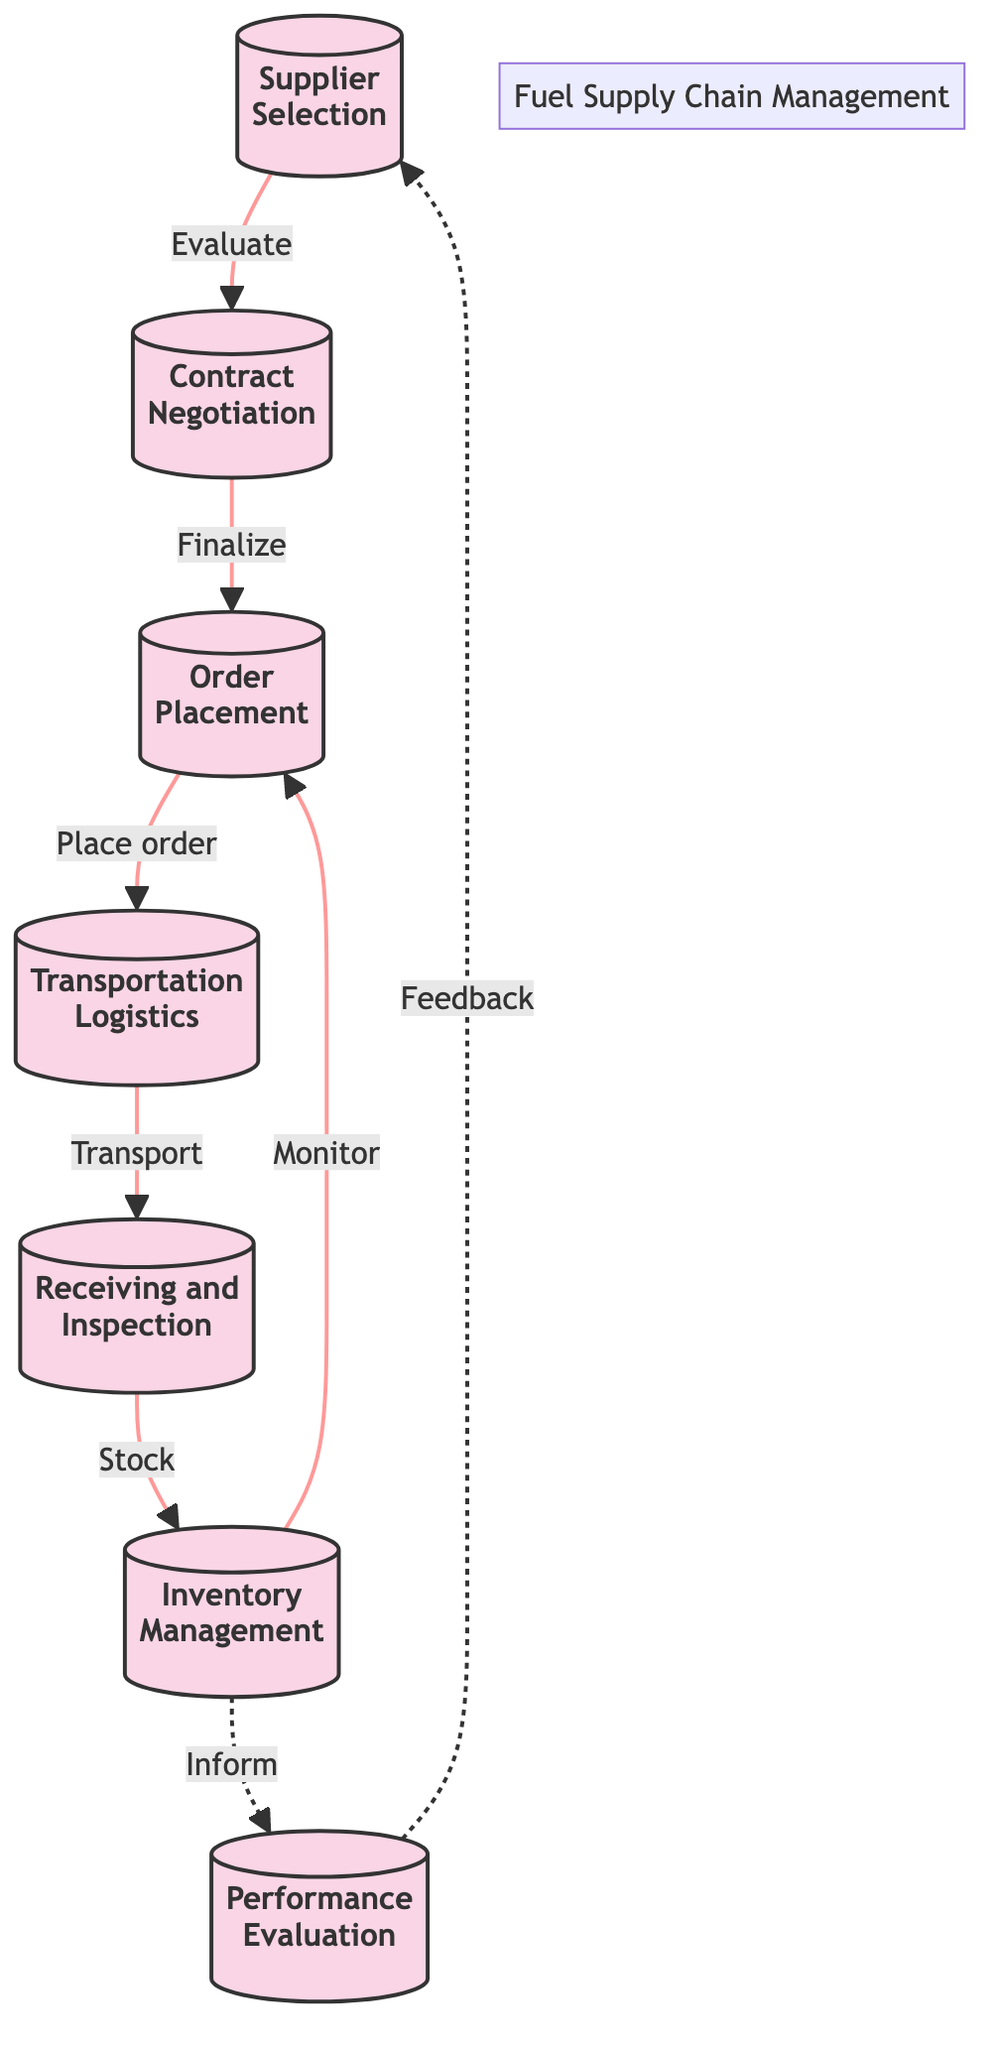What is the first step in the supply chain management process? The diagram indicates that the first step is "Supplier Selection," as it is the starting node in the flowchart.
Answer: Supplier Selection How many total processes are depicted in the diagram? By counting the nodes in the flowchart, it can be observed that there are seven distinct processes shown.
Answer: 7 Which process comes after "Contract Negotiation"? The diagram shows an arrow leading from "Contract Negotiation" to "Order Placement," indicating this is the next step in the sequence.
Answer: Order Placement What action is taken after "Transportation Logistics"? The flowchart indicates that after "Transportation Logistics," the next step is "Receiving and Inspection," as shown by the directional arrow connecting these two nodes.
Answer: Receiving and Inspection Which process receives feedback from "Performance Evaluation"? In the diagram, there is a dashed arrow pointing from "Performance Evaluation" to "Supplier Selection," indicating that this step feeds back information to the supplier selection process.
Answer: Supplier Selection What is the relationship between "Inventory Management" and "Order Placement"? The diagram shows that "Inventory Management" has a monitoring relationship with "Order Placement," indicated by the arrow returning to "Order Placement." Inventory Management informs the need for order placement based on current inventory levels.
Answer: Monitor How does "Performance Evaluation" affect future sourcing decisions? The diagram depicts that "Performance Evaluation" informs decisions about future sourcing, as it provides feedback based on supplier performance which is essential for making future supplier choices.
Answer: Feedback What indicates the circular nature of "Inventory Management" and "Order Placement"? The return arrow from "Inventory Management" to "Order Placement" signifies a circular process where inventory levels influence the ordering process, highlighting the iterative nature of managing orders and inventory.
Answer: Circular relationship 